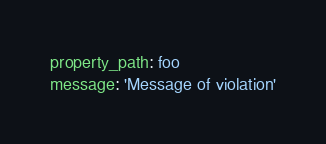Convert code to text. <code><loc_0><loc_0><loc_500><loc_500><_YAML_>property_path: foo
message: 'Message of violation'
</code> 